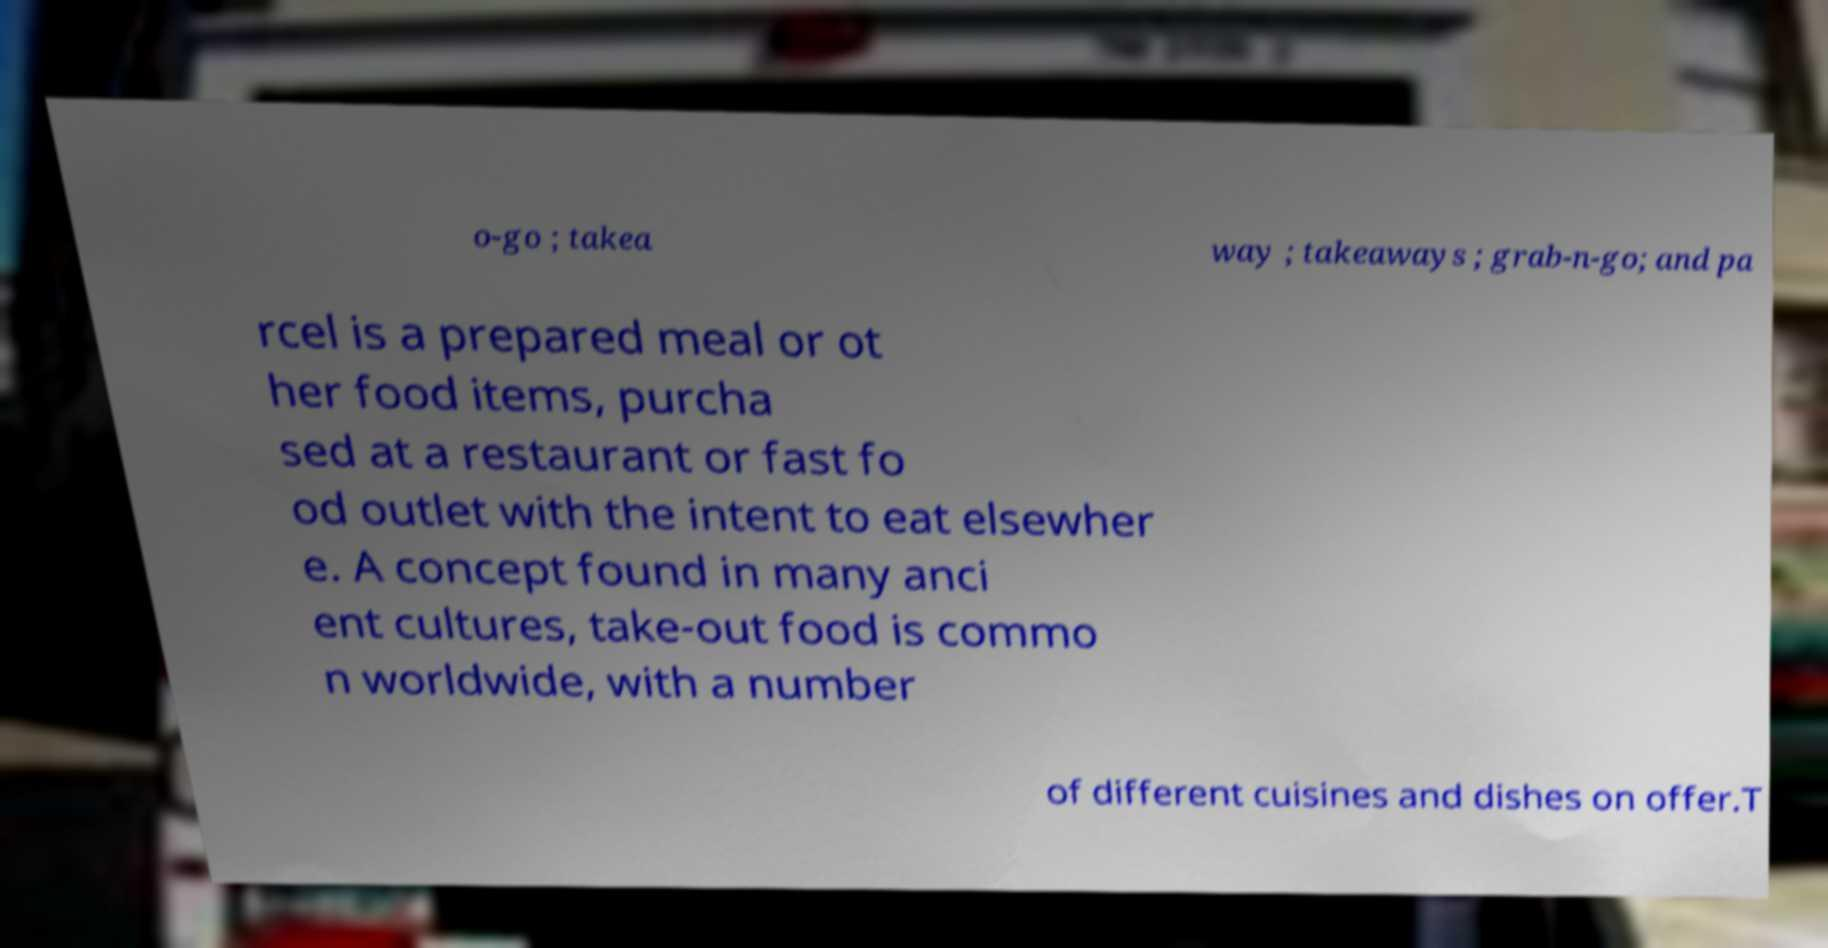Could you extract and type out the text from this image? o-go ; takea way ; takeaways ; grab-n-go; and pa rcel is a prepared meal or ot her food items, purcha sed at a restaurant or fast fo od outlet with the intent to eat elsewher e. A concept found in many anci ent cultures, take-out food is commo n worldwide, with a number of different cuisines and dishes on offer.T 